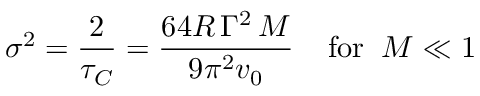<formula> <loc_0><loc_0><loc_500><loc_500>\sigma ^ { 2 } = { \frac { 2 } { \tau _ { C } } } = { \frac { 6 4 R \, \Gamma ^ { 2 } \, M } { 9 \pi ^ { 2 } v _ { 0 } } } \, f o r \, M \ll 1</formula> 